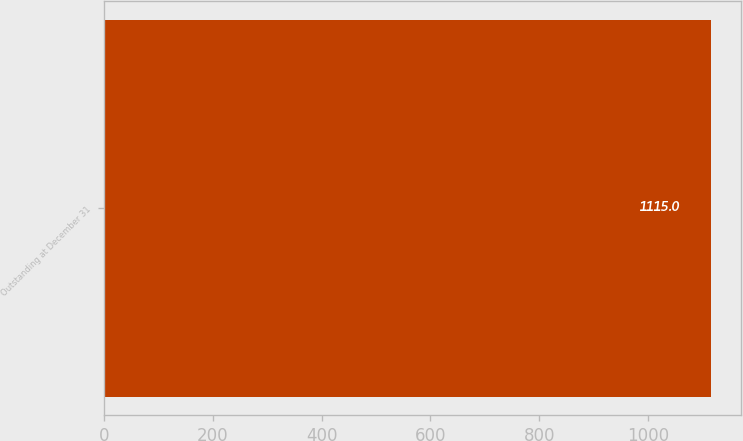<chart> <loc_0><loc_0><loc_500><loc_500><bar_chart><fcel>Outstanding at December 31<nl><fcel>1115<nl></chart> 